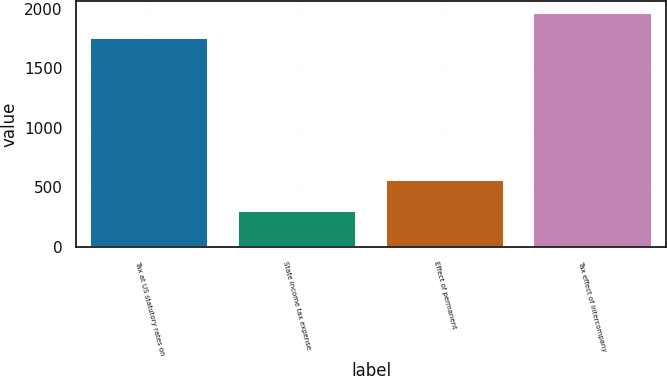Convert chart to OTSL. <chart><loc_0><loc_0><loc_500><loc_500><bar_chart><fcel>Tax at US statutory rates on<fcel>State income tax expense<fcel>Effect of permanent<fcel>Tax effect of intercompany<nl><fcel>1756<fcel>299<fcel>565<fcel>1965<nl></chart> 